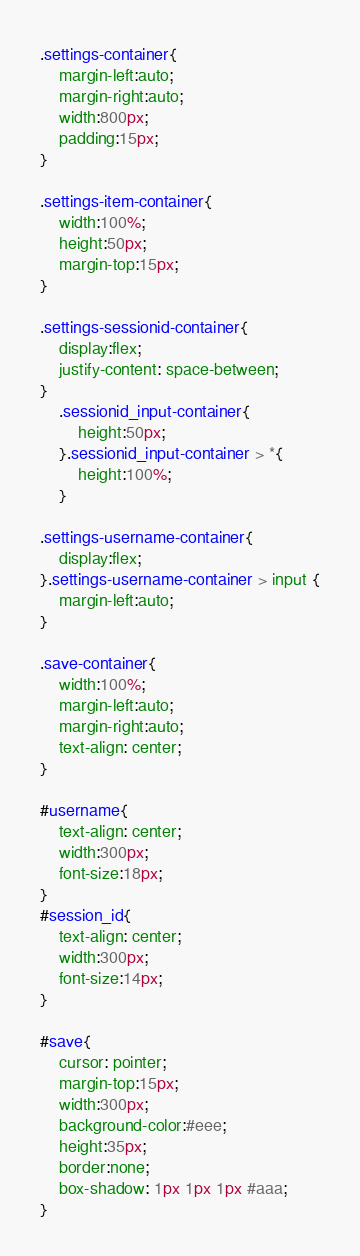Convert code to text. <code><loc_0><loc_0><loc_500><loc_500><_CSS_>.settings-container{
	margin-left:auto;
	margin-right:auto;
	width:800px;
	padding:15px;
}

.settings-item-container{
	width:100%;
	height:50px;
	margin-top:15px;
}

.settings-sessionid-container{
	display:flex;
	justify-content: space-between;
}
	.sessionid_input-container{
		height:50px;
	}.sessionid_input-container > *{
		height:100%;
	}

.settings-username-container{
	display:flex;
}.settings-username-container > input {
	margin-left:auto;
}

.save-container{
	width:100%;
	margin-left:auto;
	margin-right:auto;
	text-align: center;
}

#username{
	text-align: center;
	width:300px;
	font-size:18px;
}
#session_id{
	text-align: center;
	width:300px;
	font-size:14px;
}

#save{
	cursor: pointer;
	margin-top:15px;
	width:300px;
	background-color:#eee;
	height:35px;
	border:none;
	box-shadow: 1px 1px 1px #aaa;
}</code> 